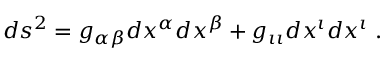<formula> <loc_0><loc_0><loc_500><loc_500>d s ^ { 2 } = g _ { \alpha \beta } d x ^ { \alpha } d x ^ { \beta } + g _ { \iota \iota } d x ^ { \iota } d x ^ { \iota } \, .</formula> 